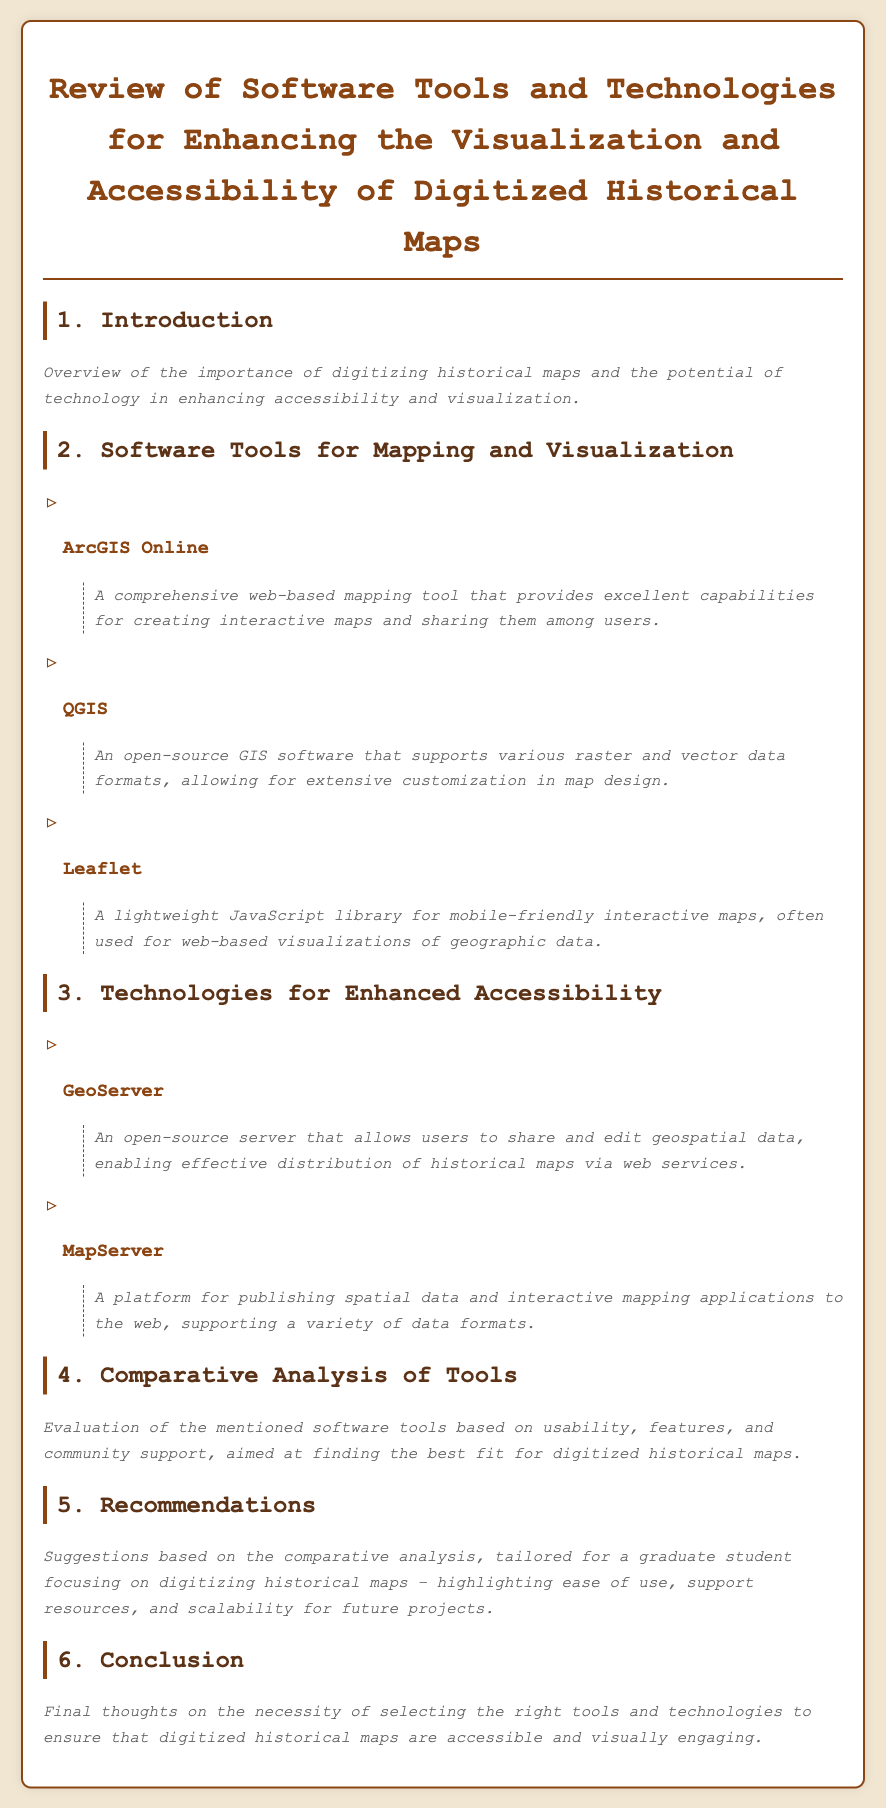What is the title of the document? The title is found in the header section of the document, summarizing its content on historical maps and visualization tools.
Answer: Review of Software Tools and Technologies for Enhancing the Visualization and Accessibility of Digitized Historical Maps What is the first software tool mentioned for mapping and visualization? The tools are listed in a specific order under the section for mapping and visualization, with the first mentioned being the primary focus of that section.
Answer: ArcGIS Online How many software tools are listed under the section for Mapping and Visualization? The number of tools can be counted directly from the sub-section titled Software Tools for Mapping and Visualization.
Answer: Three What type of server is GeoServer? The document describes GeoServer in the context of technologies for accessibility, indicating its purpose regarding geospatial data.
Answer: Open-source What section discusses the evaluation of the software tools? The section where an analysis occurs is clearly claimed in the headings, helping the reader understand its focus on tool comparison.
Answer: Comparative Analysis of Tools What is a primary recommendation for using these tools? The recommendations section offers tailored advice, hinting at ease of use and support, important for the intended user group.
Answer: Ease of use Which mapping tool is known for being open-source and customizable? The description of the tools highlights which ones belong to open-source software, providing insights into their customization capabilities.
Answer: QGIS What final thoughts are expressed in the conclusion? The conclusion summarizes the entire document's message, particularly emphasizing the importance of tool selection.
Answer: Necessity of selecting the right tools 